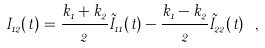Convert formula to latex. <formula><loc_0><loc_0><loc_500><loc_500>I _ { 1 2 } ( t ) = \frac { k _ { 1 } + k _ { 2 } } { 2 } \tilde { I } _ { 1 1 } ( t ) - \frac { k _ { 1 } - k _ { 2 } } { 2 } \tilde { I } _ { 2 2 } ( t ) \ ,</formula> 